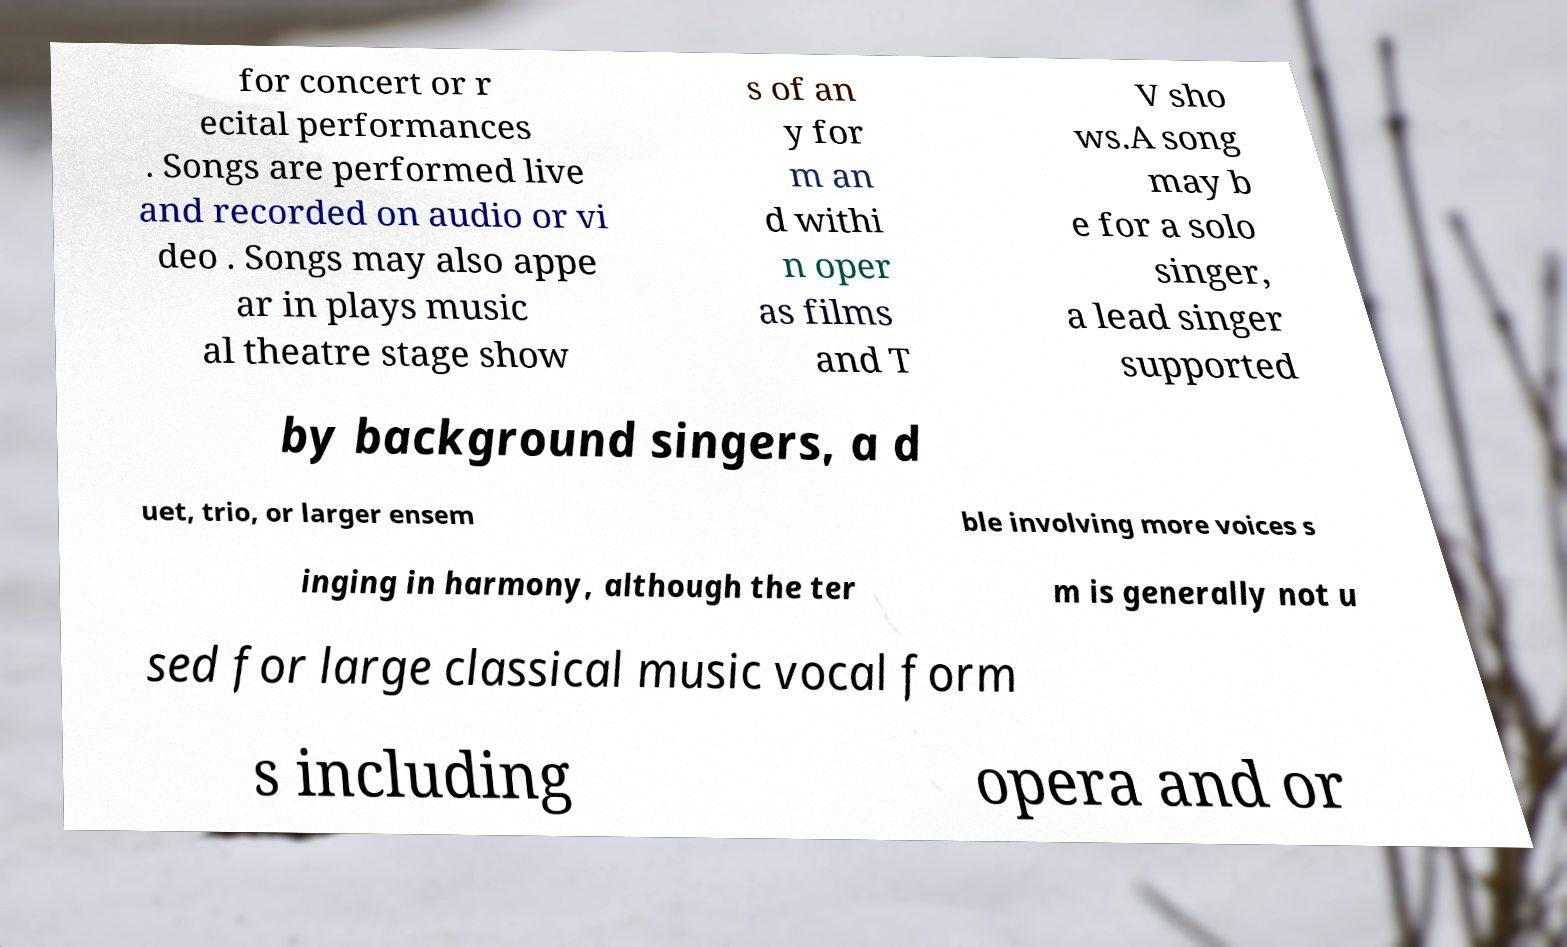I need the written content from this picture converted into text. Can you do that? for concert or r ecital performances . Songs are performed live and recorded on audio or vi deo . Songs may also appe ar in plays music al theatre stage show s of an y for m an d withi n oper as films and T V sho ws.A song may b e for a solo singer, a lead singer supported by background singers, a d uet, trio, or larger ensem ble involving more voices s inging in harmony, although the ter m is generally not u sed for large classical music vocal form s including opera and or 